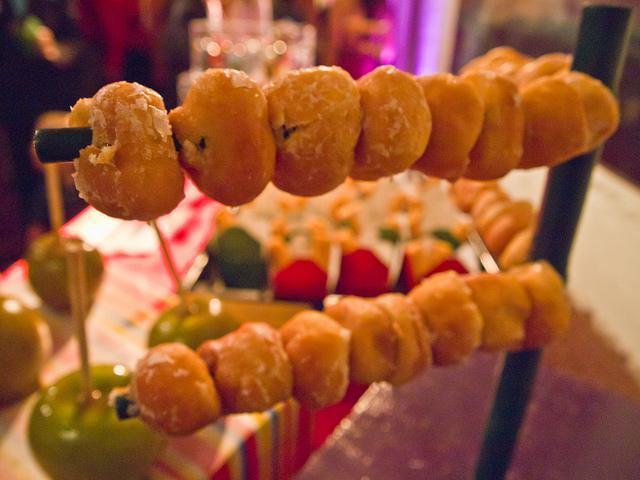How many apples can be seen?
Give a very brief answer. 4. How many donuts can you see?
Give a very brief answer. 14. How many cows are there?
Give a very brief answer. 0. 